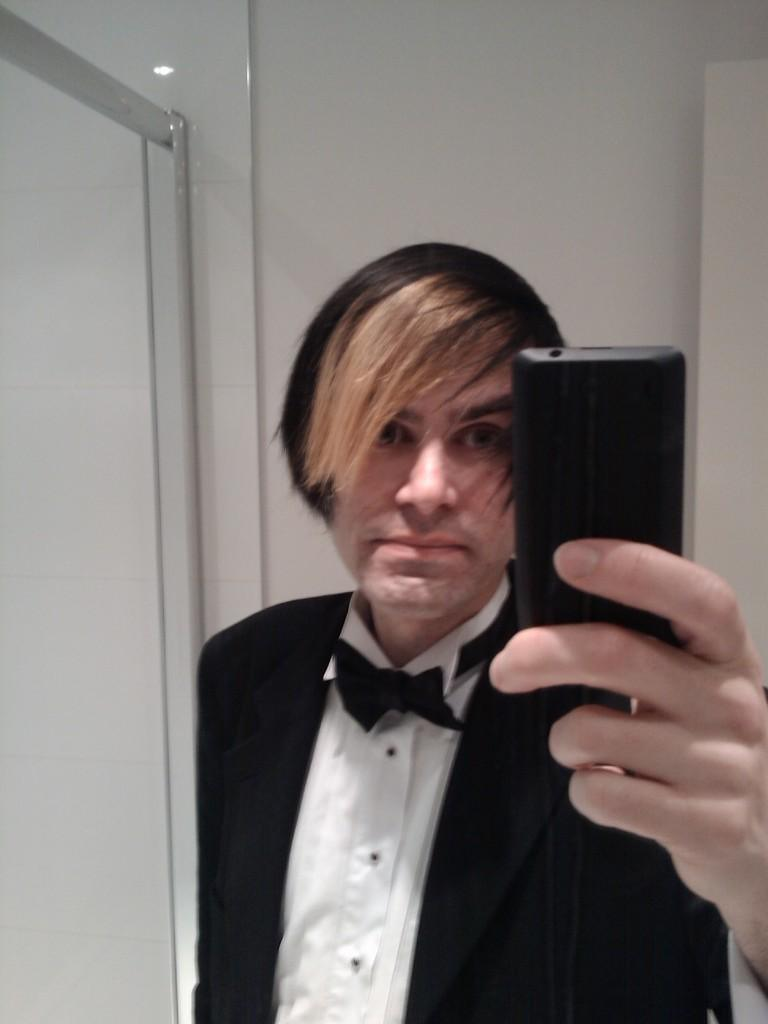Who or what is the main subject of the image? There is a person in the image. What is the person's location in relation to other objects or structures? The person is in front of a wall. What is the person wearing? The person is wearing clothes. What object is the person holding in his hand? The person is holding a phone in his hand. What type of joke is the person telling in the image? There is no indication in the image that the person is telling a joke, so it cannot be determined from the picture. 